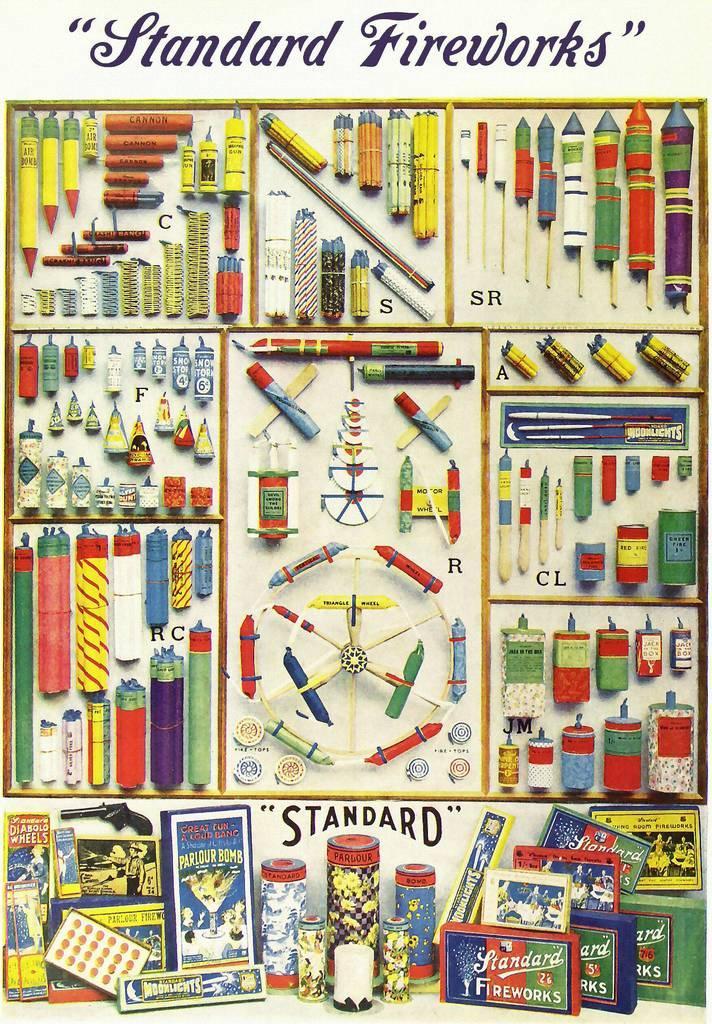<image>
Create a compact narrative representing the image presented. A poster showing "Standard Fireworks" has pictures of a lot of different types of fireworks. 